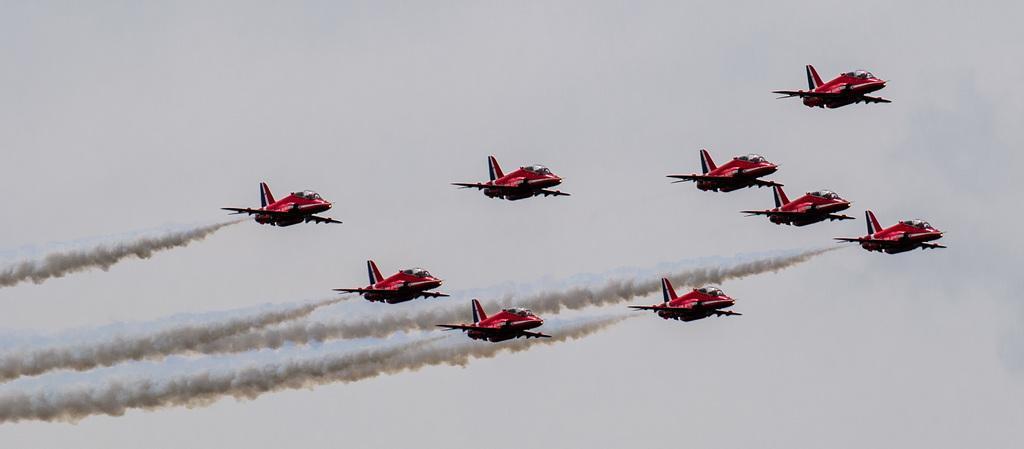Please provide a concise description of this image. In this image there are a few airplanes flying in the air with smoke behind them. In the background of the image there is sky. 